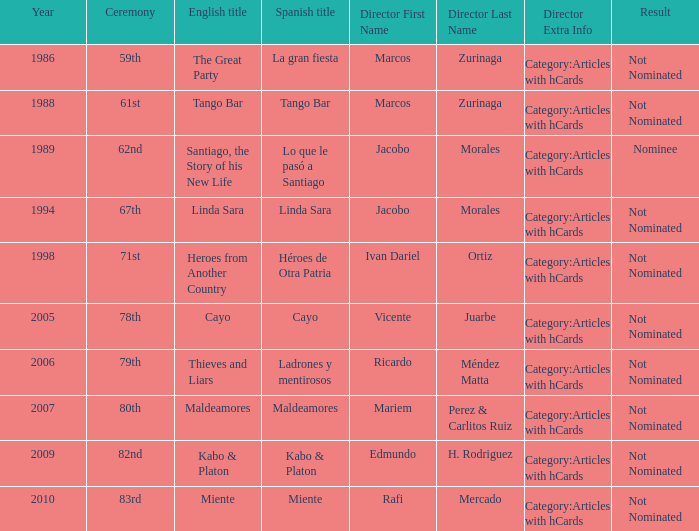Who was the director for Tango Bar? Marcos Zurinaga Category:Articles with hCards. 